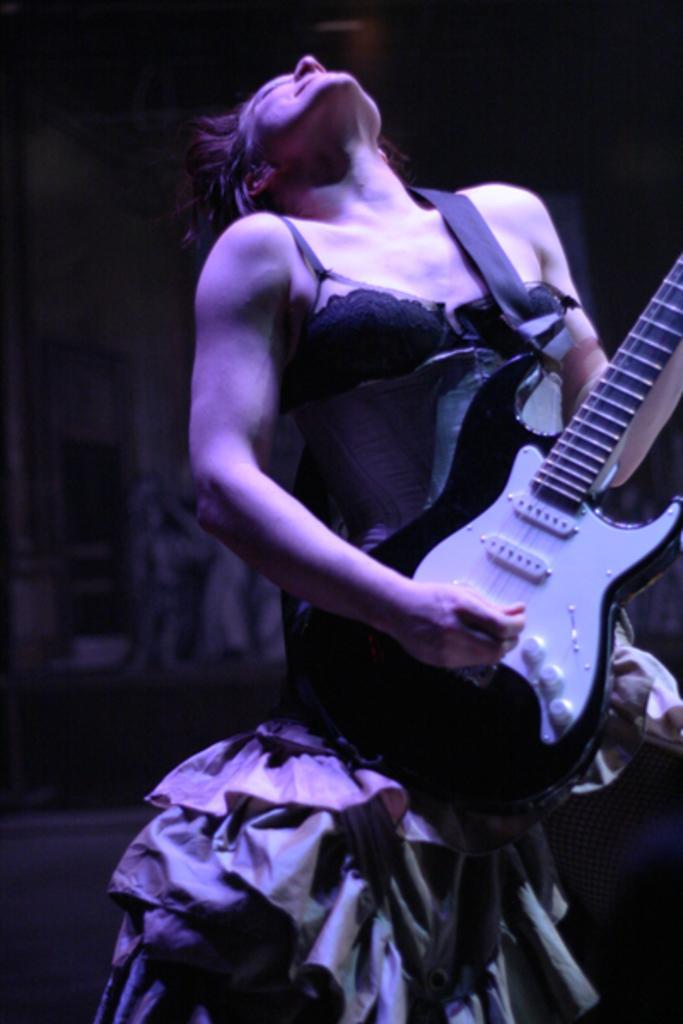How would you summarize this image in a sentence or two? In this image there is a woman standing. She is playing guitar. She is looking upwards. In the background there is wall. 